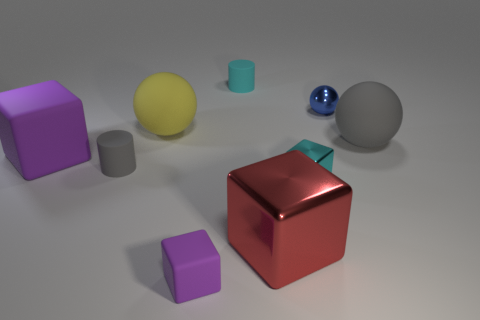There is a gray thing that is the same shape as the yellow thing; what material is it?
Keep it short and to the point. Rubber. Do the small cyan object behind the tiny metal cube and the tiny gray rubber thing have the same shape?
Your answer should be compact. Yes. The small metal sphere has what color?
Offer a very short reply. Blue. The small rubber object that is the same shape as the small cyan metallic thing is what color?
Provide a short and direct response. Purple. How many big green matte things are the same shape as the small gray matte thing?
Offer a terse response. 0. What number of things are small red things or big objects that are right of the red shiny thing?
Provide a succinct answer. 1. There is a big metal block; does it have the same color as the small rubber cylinder that is behind the small blue thing?
Your response must be concise. No. There is a sphere that is to the right of the yellow matte sphere and left of the big gray rubber ball; how big is it?
Offer a very short reply. Small. There is a big gray thing; are there any tiny metal cubes on the right side of it?
Make the answer very short. No. There is a large red block that is to the left of the blue object; is there a red shiny block that is to the left of it?
Your answer should be compact. No. 